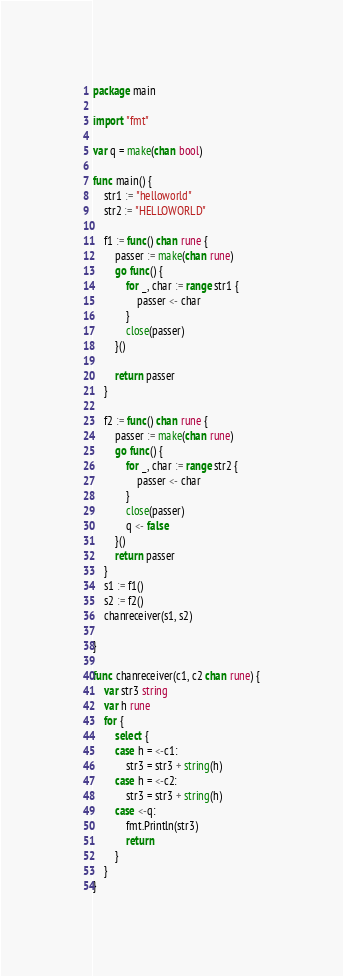Convert code to text. <code><loc_0><loc_0><loc_500><loc_500><_Go_>package main

import "fmt"

var q = make(chan bool)

func main() {
	str1 := "helloworld"
	str2 := "HELLOWORLD"

	f1 := func() chan rune {
		passer := make(chan rune)
		go func() {
			for _, char := range str1 {
				passer <- char
			}
			close(passer)
		}()

		return passer
	}

	f2 := func() chan rune {
		passer := make(chan rune)
		go func() {
			for _, char := range str2 {
				passer <- char
			}
			close(passer)
			q <- false
		}()
		return passer
	}
	s1 := f1()
	s2 := f2()
	chanreceiver(s1, s2)

}

func chanreceiver(c1, c2 chan rune) {
	var str3 string
	var h rune
	for {
		select {
		case h = <-c1:
			str3 = str3 + string(h)
		case h = <-c2:
			str3 = str3 + string(h)
		case <-q:
			fmt.Println(str3)
			return
		}
	}
}
</code> 